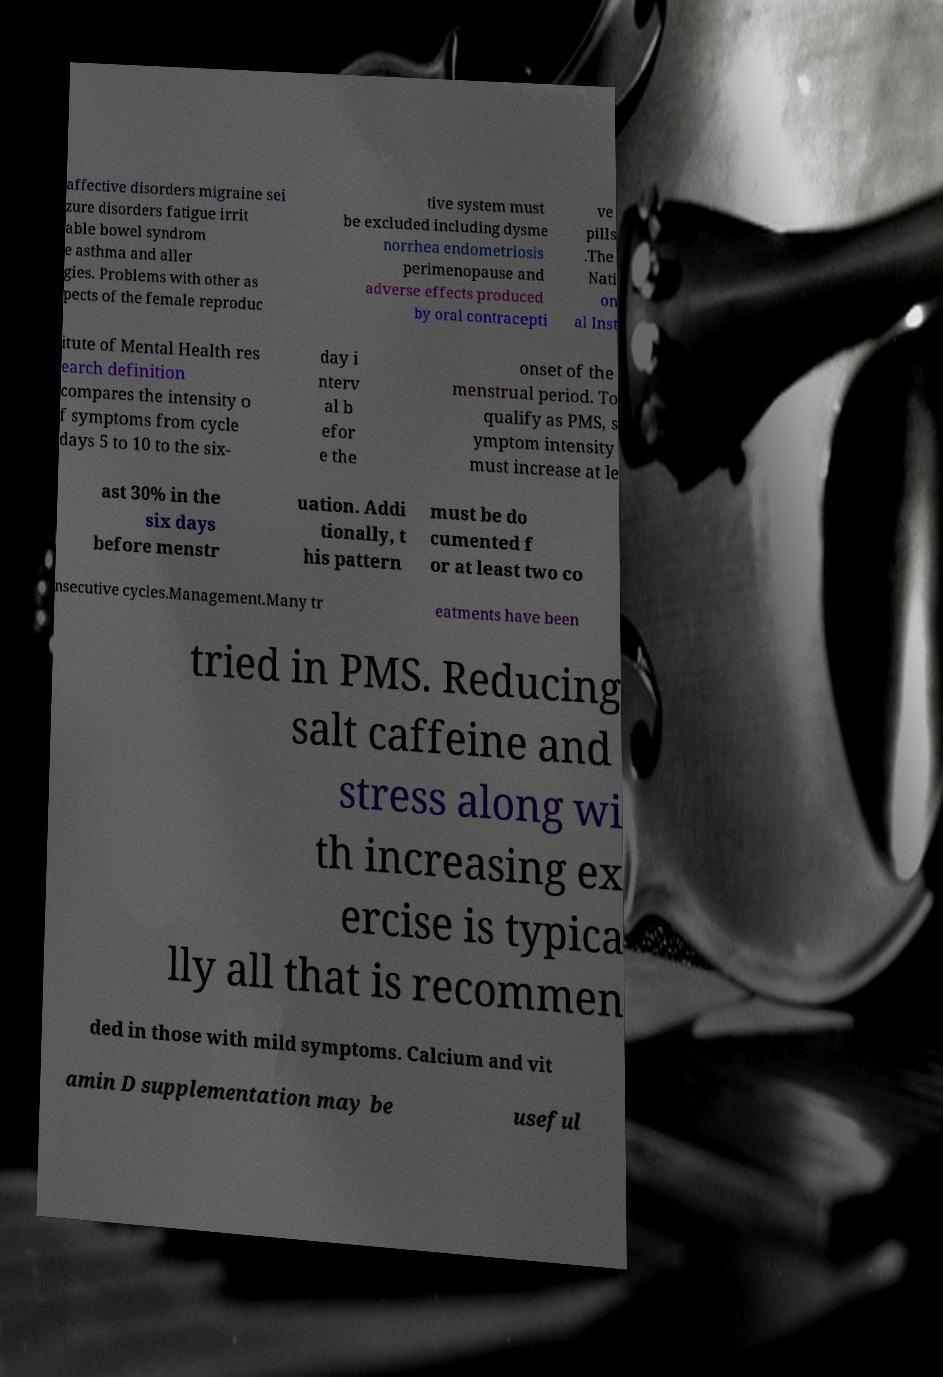Please read and relay the text visible in this image. What does it say? affective disorders migraine sei zure disorders fatigue irrit able bowel syndrom e asthma and aller gies. Problems with other as pects of the female reproduc tive system must be excluded including dysme norrhea endometriosis perimenopause and adverse effects produced by oral contracepti ve pills .The Nati on al Inst itute of Mental Health res earch definition compares the intensity o f symptoms from cycle days 5 to 10 to the six- day i nterv al b efor e the onset of the menstrual period. To qualify as PMS, s ymptom intensity must increase at le ast 30% in the six days before menstr uation. Addi tionally, t his pattern must be do cumented f or at least two co nsecutive cycles.Management.Many tr eatments have been tried in PMS. Reducing salt caffeine and stress along wi th increasing ex ercise is typica lly all that is recommen ded in those with mild symptoms. Calcium and vit amin D supplementation may be useful 